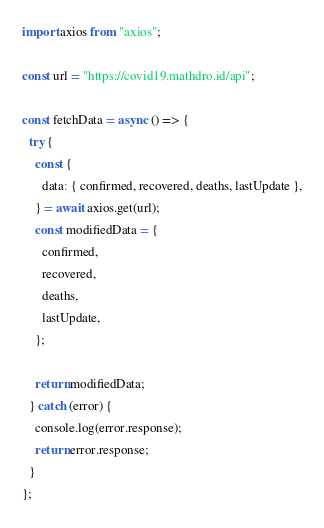Convert code to text. <code><loc_0><loc_0><loc_500><loc_500><_JavaScript_>import axios from "axios";

const url = "https://covid19.mathdro.id/api";

const fetchData = async () => {
  try {
    const {
      data: { confirmed, recovered, deaths, lastUpdate },
    } = await axios.get(url);
    const modifiedData = {
      confirmed,
      recovered,
      deaths,
      lastUpdate,
    };

    return modifiedData;
  } catch (error) {
    console.log(error.response);
    return error.response;
  }
};
</code> 